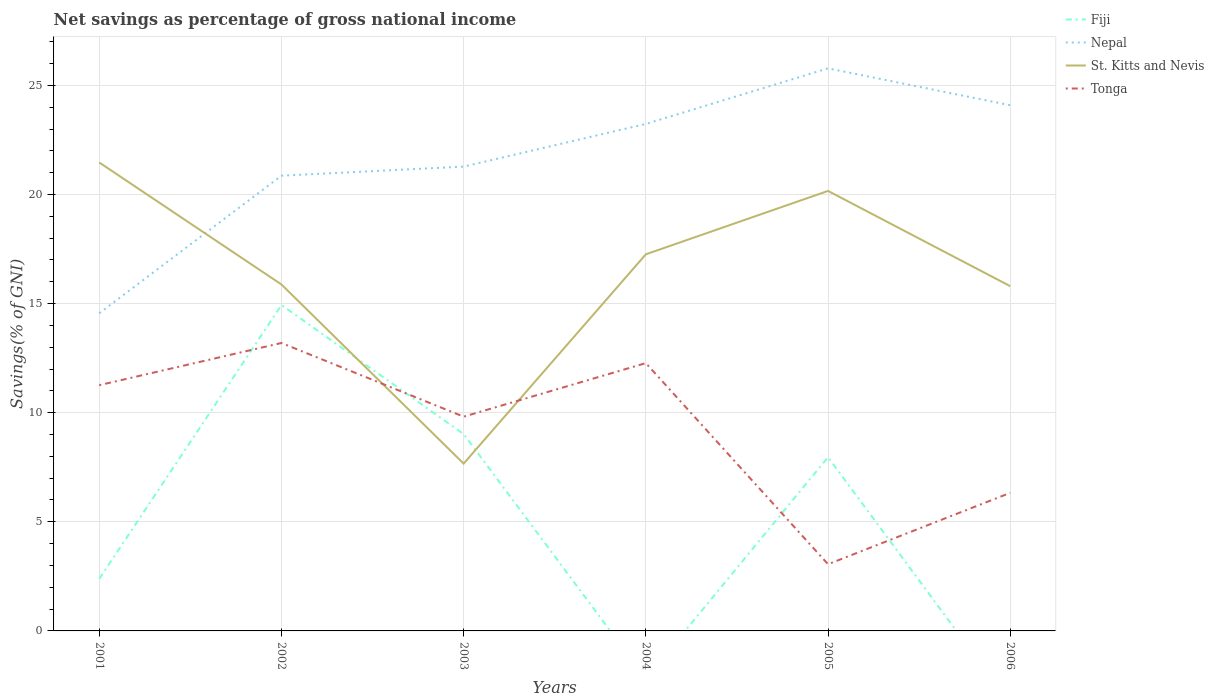What is the total total savings in Tonga in the graph?
Provide a short and direct response. 8.21. What is the difference between the highest and the second highest total savings in Tonga?
Offer a very short reply. 10.14. Are the values on the major ticks of Y-axis written in scientific E-notation?
Keep it short and to the point. No. Does the graph contain any zero values?
Your answer should be very brief. Yes. Does the graph contain grids?
Your answer should be very brief. Yes. How many legend labels are there?
Your answer should be very brief. 4. How are the legend labels stacked?
Keep it short and to the point. Vertical. What is the title of the graph?
Ensure brevity in your answer.  Net savings as percentage of gross national income. What is the label or title of the X-axis?
Keep it short and to the point. Years. What is the label or title of the Y-axis?
Keep it short and to the point. Savings(% of GNI). What is the Savings(% of GNI) in Fiji in 2001?
Offer a very short reply. 2.39. What is the Savings(% of GNI) in Nepal in 2001?
Make the answer very short. 14.56. What is the Savings(% of GNI) in St. Kitts and Nevis in 2001?
Ensure brevity in your answer.  21.47. What is the Savings(% of GNI) in Tonga in 2001?
Your answer should be very brief. 11.26. What is the Savings(% of GNI) in Fiji in 2002?
Give a very brief answer. 14.94. What is the Savings(% of GNI) of Nepal in 2002?
Your response must be concise. 20.86. What is the Savings(% of GNI) in St. Kitts and Nevis in 2002?
Make the answer very short. 15.88. What is the Savings(% of GNI) of Tonga in 2002?
Keep it short and to the point. 13.2. What is the Savings(% of GNI) in Fiji in 2003?
Ensure brevity in your answer.  9.02. What is the Savings(% of GNI) in Nepal in 2003?
Ensure brevity in your answer.  21.28. What is the Savings(% of GNI) in St. Kitts and Nevis in 2003?
Make the answer very short. 7.67. What is the Savings(% of GNI) in Tonga in 2003?
Provide a succinct answer. 9.82. What is the Savings(% of GNI) in Fiji in 2004?
Ensure brevity in your answer.  0. What is the Savings(% of GNI) in Nepal in 2004?
Offer a very short reply. 23.23. What is the Savings(% of GNI) in St. Kitts and Nevis in 2004?
Ensure brevity in your answer.  17.26. What is the Savings(% of GNI) in Tonga in 2004?
Provide a short and direct response. 12.27. What is the Savings(% of GNI) of Fiji in 2005?
Your answer should be very brief. 7.96. What is the Savings(% of GNI) of Nepal in 2005?
Provide a succinct answer. 25.78. What is the Savings(% of GNI) in St. Kitts and Nevis in 2005?
Make the answer very short. 20.16. What is the Savings(% of GNI) in Tonga in 2005?
Offer a terse response. 3.06. What is the Savings(% of GNI) in Fiji in 2006?
Your answer should be compact. 0. What is the Savings(% of GNI) in Nepal in 2006?
Your response must be concise. 24.09. What is the Savings(% of GNI) of St. Kitts and Nevis in 2006?
Provide a succinct answer. 15.8. What is the Savings(% of GNI) in Tonga in 2006?
Provide a short and direct response. 6.33. Across all years, what is the maximum Savings(% of GNI) in Fiji?
Provide a short and direct response. 14.94. Across all years, what is the maximum Savings(% of GNI) of Nepal?
Offer a very short reply. 25.78. Across all years, what is the maximum Savings(% of GNI) of St. Kitts and Nevis?
Ensure brevity in your answer.  21.47. Across all years, what is the maximum Savings(% of GNI) in Tonga?
Offer a terse response. 13.2. Across all years, what is the minimum Savings(% of GNI) in Fiji?
Give a very brief answer. 0. Across all years, what is the minimum Savings(% of GNI) of Nepal?
Give a very brief answer. 14.56. Across all years, what is the minimum Savings(% of GNI) of St. Kitts and Nevis?
Provide a short and direct response. 7.67. Across all years, what is the minimum Savings(% of GNI) of Tonga?
Your response must be concise. 3.06. What is the total Savings(% of GNI) in Fiji in the graph?
Offer a very short reply. 34.3. What is the total Savings(% of GNI) in Nepal in the graph?
Your answer should be very brief. 129.81. What is the total Savings(% of GNI) in St. Kitts and Nevis in the graph?
Offer a terse response. 98.24. What is the total Savings(% of GNI) in Tonga in the graph?
Your response must be concise. 55.93. What is the difference between the Savings(% of GNI) in Fiji in 2001 and that in 2002?
Keep it short and to the point. -12.55. What is the difference between the Savings(% of GNI) of Nepal in 2001 and that in 2002?
Keep it short and to the point. -6.3. What is the difference between the Savings(% of GNI) in St. Kitts and Nevis in 2001 and that in 2002?
Provide a short and direct response. 5.59. What is the difference between the Savings(% of GNI) in Tonga in 2001 and that in 2002?
Ensure brevity in your answer.  -1.93. What is the difference between the Savings(% of GNI) of Fiji in 2001 and that in 2003?
Ensure brevity in your answer.  -6.63. What is the difference between the Savings(% of GNI) of Nepal in 2001 and that in 2003?
Provide a short and direct response. -6.72. What is the difference between the Savings(% of GNI) in St. Kitts and Nevis in 2001 and that in 2003?
Make the answer very short. 13.8. What is the difference between the Savings(% of GNI) in Tonga in 2001 and that in 2003?
Give a very brief answer. 1.44. What is the difference between the Savings(% of GNI) of Nepal in 2001 and that in 2004?
Keep it short and to the point. -8.68. What is the difference between the Savings(% of GNI) of St. Kitts and Nevis in 2001 and that in 2004?
Ensure brevity in your answer.  4.21. What is the difference between the Savings(% of GNI) of Tonga in 2001 and that in 2004?
Offer a very short reply. -1.01. What is the difference between the Savings(% of GNI) of Fiji in 2001 and that in 2005?
Make the answer very short. -5.58. What is the difference between the Savings(% of GNI) in Nepal in 2001 and that in 2005?
Your answer should be compact. -11.22. What is the difference between the Savings(% of GNI) of St. Kitts and Nevis in 2001 and that in 2005?
Provide a short and direct response. 1.3. What is the difference between the Savings(% of GNI) in Tonga in 2001 and that in 2005?
Ensure brevity in your answer.  8.21. What is the difference between the Savings(% of GNI) of Nepal in 2001 and that in 2006?
Your answer should be very brief. -9.53. What is the difference between the Savings(% of GNI) of St. Kitts and Nevis in 2001 and that in 2006?
Keep it short and to the point. 5.67. What is the difference between the Savings(% of GNI) in Tonga in 2001 and that in 2006?
Make the answer very short. 4.93. What is the difference between the Savings(% of GNI) in Fiji in 2002 and that in 2003?
Make the answer very short. 5.92. What is the difference between the Savings(% of GNI) of Nepal in 2002 and that in 2003?
Keep it short and to the point. -0.42. What is the difference between the Savings(% of GNI) in St. Kitts and Nevis in 2002 and that in 2003?
Provide a short and direct response. 8.21. What is the difference between the Savings(% of GNI) of Tonga in 2002 and that in 2003?
Provide a short and direct response. 3.38. What is the difference between the Savings(% of GNI) in Nepal in 2002 and that in 2004?
Your response must be concise. -2.37. What is the difference between the Savings(% of GNI) in St. Kitts and Nevis in 2002 and that in 2004?
Your answer should be very brief. -1.38. What is the difference between the Savings(% of GNI) of Tonga in 2002 and that in 2004?
Ensure brevity in your answer.  0.92. What is the difference between the Savings(% of GNI) of Fiji in 2002 and that in 2005?
Offer a terse response. 6.97. What is the difference between the Savings(% of GNI) in Nepal in 2002 and that in 2005?
Give a very brief answer. -4.92. What is the difference between the Savings(% of GNI) in St. Kitts and Nevis in 2002 and that in 2005?
Offer a terse response. -4.29. What is the difference between the Savings(% of GNI) of Tonga in 2002 and that in 2005?
Keep it short and to the point. 10.14. What is the difference between the Savings(% of GNI) in Nepal in 2002 and that in 2006?
Provide a succinct answer. -3.23. What is the difference between the Savings(% of GNI) in St. Kitts and Nevis in 2002 and that in 2006?
Provide a short and direct response. 0.08. What is the difference between the Savings(% of GNI) in Tonga in 2002 and that in 2006?
Ensure brevity in your answer.  6.87. What is the difference between the Savings(% of GNI) in Nepal in 2003 and that in 2004?
Your response must be concise. -1.96. What is the difference between the Savings(% of GNI) of St. Kitts and Nevis in 2003 and that in 2004?
Ensure brevity in your answer.  -9.59. What is the difference between the Savings(% of GNI) in Tonga in 2003 and that in 2004?
Make the answer very short. -2.45. What is the difference between the Savings(% of GNI) of Fiji in 2003 and that in 2005?
Give a very brief answer. 1.06. What is the difference between the Savings(% of GNI) of Nepal in 2003 and that in 2005?
Offer a very short reply. -4.5. What is the difference between the Savings(% of GNI) in St. Kitts and Nevis in 2003 and that in 2005?
Ensure brevity in your answer.  -12.5. What is the difference between the Savings(% of GNI) in Tonga in 2003 and that in 2005?
Ensure brevity in your answer.  6.76. What is the difference between the Savings(% of GNI) of Nepal in 2003 and that in 2006?
Your answer should be very brief. -2.81. What is the difference between the Savings(% of GNI) of St. Kitts and Nevis in 2003 and that in 2006?
Your answer should be compact. -8.13. What is the difference between the Savings(% of GNI) in Tonga in 2003 and that in 2006?
Your answer should be compact. 3.49. What is the difference between the Savings(% of GNI) in Nepal in 2004 and that in 2005?
Offer a terse response. -2.55. What is the difference between the Savings(% of GNI) in St. Kitts and Nevis in 2004 and that in 2005?
Offer a terse response. -2.9. What is the difference between the Savings(% of GNI) of Tonga in 2004 and that in 2005?
Your answer should be very brief. 9.22. What is the difference between the Savings(% of GNI) of Nepal in 2004 and that in 2006?
Your answer should be very brief. -0.86. What is the difference between the Savings(% of GNI) in St. Kitts and Nevis in 2004 and that in 2006?
Give a very brief answer. 1.46. What is the difference between the Savings(% of GNI) in Tonga in 2004 and that in 2006?
Your answer should be compact. 5.95. What is the difference between the Savings(% of GNI) of Nepal in 2005 and that in 2006?
Ensure brevity in your answer.  1.69. What is the difference between the Savings(% of GNI) in St. Kitts and Nevis in 2005 and that in 2006?
Keep it short and to the point. 4.36. What is the difference between the Savings(% of GNI) in Tonga in 2005 and that in 2006?
Give a very brief answer. -3.27. What is the difference between the Savings(% of GNI) in Fiji in 2001 and the Savings(% of GNI) in Nepal in 2002?
Your answer should be very brief. -18.48. What is the difference between the Savings(% of GNI) of Fiji in 2001 and the Savings(% of GNI) of St. Kitts and Nevis in 2002?
Provide a succinct answer. -13.49. What is the difference between the Savings(% of GNI) of Fiji in 2001 and the Savings(% of GNI) of Tonga in 2002?
Offer a very short reply. -10.81. What is the difference between the Savings(% of GNI) of Nepal in 2001 and the Savings(% of GNI) of St. Kitts and Nevis in 2002?
Your answer should be very brief. -1.32. What is the difference between the Savings(% of GNI) in Nepal in 2001 and the Savings(% of GNI) in Tonga in 2002?
Ensure brevity in your answer.  1.36. What is the difference between the Savings(% of GNI) in St. Kitts and Nevis in 2001 and the Savings(% of GNI) in Tonga in 2002?
Give a very brief answer. 8.27. What is the difference between the Savings(% of GNI) of Fiji in 2001 and the Savings(% of GNI) of Nepal in 2003?
Make the answer very short. -18.89. What is the difference between the Savings(% of GNI) of Fiji in 2001 and the Savings(% of GNI) of St. Kitts and Nevis in 2003?
Your response must be concise. -5.28. What is the difference between the Savings(% of GNI) of Fiji in 2001 and the Savings(% of GNI) of Tonga in 2003?
Keep it short and to the point. -7.43. What is the difference between the Savings(% of GNI) of Nepal in 2001 and the Savings(% of GNI) of St. Kitts and Nevis in 2003?
Your answer should be compact. 6.89. What is the difference between the Savings(% of GNI) in Nepal in 2001 and the Savings(% of GNI) in Tonga in 2003?
Your response must be concise. 4.74. What is the difference between the Savings(% of GNI) of St. Kitts and Nevis in 2001 and the Savings(% of GNI) of Tonga in 2003?
Offer a terse response. 11.65. What is the difference between the Savings(% of GNI) of Fiji in 2001 and the Savings(% of GNI) of Nepal in 2004?
Provide a succinct answer. -20.85. What is the difference between the Savings(% of GNI) in Fiji in 2001 and the Savings(% of GNI) in St. Kitts and Nevis in 2004?
Your response must be concise. -14.87. What is the difference between the Savings(% of GNI) in Fiji in 2001 and the Savings(% of GNI) in Tonga in 2004?
Give a very brief answer. -9.89. What is the difference between the Savings(% of GNI) of Nepal in 2001 and the Savings(% of GNI) of St. Kitts and Nevis in 2004?
Your response must be concise. -2.7. What is the difference between the Savings(% of GNI) in Nepal in 2001 and the Savings(% of GNI) in Tonga in 2004?
Your answer should be compact. 2.29. What is the difference between the Savings(% of GNI) in St. Kitts and Nevis in 2001 and the Savings(% of GNI) in Tonga in 2004?
Ensure brevity in your answer.  9.2. What is the difference between the Savings(% of GNI) of Fiji in 2001 and the Savings(% of GNI) of Nepal in 2005?
Make the answer very short. -23.4. What is the difference between the Savings(% of GNI) of Fiji in 2001 and the Savings(% of GNI) of St. Kitts and Nevis in 2005?
Provide a succinct answer. -17.78. What is the difference between the Savings(% of GNI) in Fiji in 2001 and the Savings(% of GNI) in Tonga in 2005?
Give a very brief answer. -0.67. What is the difference between the Savings(% of GNI) of Nepal in 2001 and the Savings(% of GNI) of St. Kitts and Nevis in 2005?
Give a very brief answer. -5.6. What is the difference between the Savings(% of GNI) in Nepal in 2001 and the Savings(% of GNI) in Tonga in 2005?
Your response must be concise. 11.5. What is the difference between the Savings(% of GNI) of St. Kitts and Nevis in 2001 and the Savings(% of GNI) of Tonga in 2005?
Make the answer very short. 18.41. What is the difference between the Savings(% of GNI) of Fiji in 2001 and the Savings(% of GNI) of Nepal in 2006?
Provide a succinct answer. -21.71. What is the difference between the Savings(% of GNI) in Fiji in 2001 and the Savings(% of GNI) in St. Kitts and Nevis in 2006?
Your answer should be compact. -13.41. What is the difference between the Savings(% of GNI) of Fiji in 2001 and the Savings(% of GNI) of Tonga in 2006?
Provide a succinct answer. -3.94. What is the difference between the Savings(% of GNI) of Nepal in 2001 and the Savings(% of GNI) of St. Kitts and Nevis in 2006?
Keep it short and to the point. -1.24. What is the difference between the Savings(% of GNI) in Nepal in 2001 and the Savings(% of GNI) in Tonga in 2006?
Provide a short and direct response. 8.23. What is the difference between the Savings(% of GNI) of St. Kitts and Nevis in 2001 and the Savings(% of GNI) of Tonga in 2006?
Give a very brief answer. 15.14. What is the difference between the Savings(% of GNI) of Fiji in 2002 and the Savings(% of GNI) of Nepal in 2003?
Ensure brevity in your answer.  -6.34. What is the difference between the Savings(% of GNI) in Fiji in 2002 and the Savings(% of GNI) in St. Kitts and Nevis in 2003?
Ensure brevity in your answer.  7.27. What is the difference between the Savings(% of GNI) in Fiji in 2002 and the Savings(% of GNI) in Tonga in 2003?
Your answer should be compact. 5.12. What is the difference between the Savings(% of GNI) of Nepal in 2002 and the Savings(% of GNI) of St. Kitts and Nevis in 2003?
Ensure brevity in your answer.  13.2. What is the difference between the Savings(% of GNI) of Nepal in 2002 and the Savings(% of GNI) of Tonga in 2003?
Your answer should be very brief. 11.04. What is the difference between the Savings(% of GNI) in St. Kitts and Nevis in 2002 and the Savings(% of GNI) in Tonga in 2003?
Provide a succinct answer. 6.06. What is the difference between the Savings(% of GNI) in Fiji in 2002 and the Savings(% of GNI) in Nepal in 2004?
Ensure brevity in your answer.  -8.3. What is the difference between the Savings(% of GNI) in Fiji in 2002 and the Savings(% of GNI) in St. Kitts and Nevis in 2004?
Your answer should be very brief. -2.32. What is the difference between the Savings(% of GNI) of Fiji in 2002 and the Savings(% of GNI) of Tonga in 2004?
Offer a very short reply. 2.66. What is the difference between the Savings(% of GNI) of Nepal in 2002 and the Savings(% of GNI) of St. Kitts and Nevis in 2004?
Keep it short and to the point. 3.6. What is the difference between the Savings(% of GNI) in Nepal in 2002 and the Savings(% of GNI) in Tonga in 2004?
Your response must be concise. 8.59. What is the difference between the Savings(% of GNI) in St. Kitts and Nevis in 2002 and the Savings(% of GNI) in Tonga in 2004?
Your answer should be compact. 3.6. What is the difference between the Savings(% of GNI) of Fiji in 2002 and the Savings(% of GNI) of Nepal in 2005?
Provide a succinct answer. -10.85. What is the difference between the Savings(% of GNI) in Fiji in 2002 and the Savings(% of GNI) in St. Kitts and Nevis in 2005?
Provide a short and direct response. -5.23. What is the difference between the Savings(% of GNI) of Fiji in 2002 and the Savings(% of GNI) of Tonga in 2005?
Offer a terse response. 11.88. What is the difference between the Savings(% of GNI) of Nepal in 2002 and the Savings(% of GNI) of St. Kitts and Nevis in 2005?
Your answer should be very brief. 0.7. What is the difference between the Savings(% of GNI) in Nepal in 2002 and the Savings(% of GNI) in Tonga in 2005?
Your answer should be compact. 17.81. What is the difference between the Savings(% of GNI) of St. Kitts and Nevis in 2002 and the Savings(% of GNI) of Tonga in 2005?
Make the answer very short. 12.82. What is the difference between the Savings(% of GNI) of Fiji in 2002 and the Savings(% of GNI) of Nepal in 2006?
Provide a succinct answer. -9.16. What is the difference between the Savings(% of GNI) of Fiji in 2002 and the Savings(% of GNI) of St. Kitts and Nevis in 2006?
Ensure brevity in your answer.  -0.86. What is the difference between the Savings(% of GNI) of Fiji in 2002 and the Savings(% of GNI) of Tonga in 2006?
Offer a very short reply. 8.61. What is the difference between the Savings(% of GNI) of Nepal in 2002 and the Savings(% of GNI) of St. Kitts and Nevis in 2006?
Ensure brevity in your answer.  5.06. What is the difference between the Savings(% of GNI) of Nepal in 2002 and the Savings(% of GNI) of Tonga in 2006?
Keep it short and to the point. 14.54. What is the difference between the Savings(% of GNI) of St. Kitts and Nevis in 2002 and the Savings(% of GNI) of Tonga in 2006?
Provide a short and direct response. 9.55. What is the difference between the Savings(% of GNI) in Fiji in 2003 and the Savings(% of GNI) in Nepal in 2004?
Keep it short and to the point. -14.21. What is the difference between the Savings(% of GNI) in Fiji in 2003 and the Savings(% of GNI) in St. Kitts and Nevis in 2004?
Keep it short and to the point. -8.24. What is the difference between the Savings(% of GNI) of Fiji in 2003 and the Savings(% of GNI) of Tonga in 2004?
Provide a succinct answer. -3.25. What is the difference between the Savings(% of GNI) in Nepal in 2003 and the Savings(% of GNI) in St. Kitts and Nevis in 2004?
Your response must be concise. 4.02. What is the difference between the Savings(% of GNI) of Nepal in 2003 and the Savings(% of GNI) of Tonga in 2004?
Your answer should be very brief. 9.01. What is the difference between the Savings(% of GNI) of St. Kitts and Nevis in 2003 and the Savings(% of GNI) of Tonga in 2004?
Your answer should be very brief. -4.61. What is the difference between the Savings(% of GNI) in Fiji in 2003 and the Savings(% of GNI) in Nepal in 2005?
Offer a terse response. -16.76. What is the difference between the Savings(% of GNI) in Fiji in 2003 and the Savings(% of GNI) in St. Kitts and Nevis in 2005?
Your answer should be compact. -11.14. What is the difference between the Savings(% of GNI) in Fiji in 2003 and the Savings(% of GNI) in Tonga in 2005?
Give a very brief answer. 5.96. What is the difference between the Savings(% of GNI) in Nepal in 2003 and the Savings(% of GNI) in St. Kitts and Nevis in 2005?
Ensure brevity in your answer.  1.11. What is the difference between the Savings(% of GNI) in Nepal in 2003 and the Savings(% of GNI) in Tonga in 2005?
Ensure brevity in your answer.  18.22. What is the difference between the Savings(% of GNI) in St. Kitts and Nevis in 2003 and the Savings(% of GNI) in Tonga in 2005?
Your answer should be compact. 4.61. What is the difference between the Savings(% of GNI) of Fiji in 2003 and the Savings(% of GNI) of Nepal in 2006?
Offer a very short reply. -15.07. What is the difference between the Savings(% of GNI) of Fiji in 2003 and the Savings(% of GNI) of St. Kitts and Nevis in 2006?
Your response must be concise. -6.78. What is the difference between the Savings(% of GNI) of Fiji in 2003 and the Savings(% of GNI) of Tonga in 2006?
Your response must be concise. 2.69. What is the difference between the Savings(% of GNI) in Nepal in 2003 and the Savings(% of GNI) in St. Kitts and Nevis in 2006?
Your answer should be compact. 5.48. What is the difference between the Savings(% of GNI) of Nepal in 2003 and the Savings(% of GNI) of Tonga in 2006?
Provide a succinct answer. 14.95. What is the difference between the Savings(% of GNI) of St. Kitts and Nevis in 2003 and the Savings(% of GNI) of Tonga in 2006?
Your response must be concise. 1.34. What is the difference between the Savings(% of GNI) of Nepal in 2004 and the Savings(% of GNI) of St. Kitts and Nevis in 2005?
Your answer should be compact. 3.07. What is the difference between the Savings(% of GNI) of Nepal in 2004 and the Savings(% of GNI) of Tonga in 2005?
Provide a succinct answer. 20.18. What is the difference between the Savings(% of GNI) in St. Kitts and Nevis in 2004 and the Savings(% of GNI) in Tonga in 2005?
Give a very brief answer. 14.2. What is the difference between the Savings(% of GNI) in Nepal in 2004 and the Savings(% of GNI) in St. Kitts and Nevis in 2006?
Provide a succinct answer. 7.44. What is the difference between the Savings(% of GNI) of Nepal in 2004 and the Savings(% of GNI) of Tonga in 2006?
Give a very brief answer. 16.91. What is the difference between the Savings(% of GNI) in St. Kitts and Nevis in 2004 and the Savings(% of GNI) in Tonga in 2006?
Your response must be concise. 10.93. What is the difference between the Savings(% of GNI) of Fiji in 2005 and the Savings(% of GNI) of Nepal in 2006?
Provide a succinct answer. -16.13. What is the difference between the Savings(% of GNI) in Fiji in 2005 and the Savings(% of GNI) in St. Kitts and Nevis in 2006?
Give a very brief answer. -7.84. What is the difference between the Savings(% of GNI) of Fiji in 2005 and the Savings(% of GNI) of Tonga in 2006?
Offer a very short reply. 1.63. What is the difference between the Savings(% of GNI) of Nepal in 2005 and the Savings(% of GNI) of St. Kitts and Nevis in 2006?
Your response must be concise. 9.98. What is the difference between the Savings(% of GNI) in Nepal in 2005 and the Savings(% of GNI) in Tonga in 2006?
Your answer should be very brief. 19.45. What is the difference between the Savings(% of GNI) of St. Kitts and Nevis in 2005 and the Savings(% of GNI) of Tonga in 2006?
Ensure brevity in your answer.  13.84. What is the average Savings(% of GNI) of Fiji per year?
Offer a very short reply. 5.72. What is the average Savings(% of GNI) of Nepal per year?
Ensure brevity in your answer.  21.64. What is the average Savings(% of GNI) in St. Kitts and Nevis per year?
Provide a succinct answer. 16.37. What is the average Savings(% of GNI) in Tonga per year?
Make the answer very short. 9.32. In the year 2001, what is the difference between the Savings(% of GNI) in Fiji and Savings(% of GNI) in Nepal?
Your response must be concise. -12.17. In the year 2001, what is the difference between the Savings(% of GNI) in Fiji and Savings(% of GNI) in St. Kitts and Nevis?
Provide a succinct answer. -19.08. In the year 2001, what is the difference between the Savings(% of GNI) in Fiji and Savings(% of GNI) in Tonga?
Provide a succinct answer. -8.88. In the year 2001, what is the difference between the Savings(% of GNI) of Nepal and Savings(% of GNI) of St. Kitts and Nevis?
Offer a terse response. -6.91. In the year 2001, what is the difference between the Savings(% of GNI) in Nepal and Savings(% of GNI) in Tonga?
Your answer should be compact. 3.3. In the year 2001, what is the difference between the Savings(% of GNI) of St. Kitts and Nevis and Savings(% of GNI) of Tonga?
Your answer should be very brief. 10.21. In the year 2002, what is the difference between the Savings(% of GNI) of Fiji and Savings(% of GNI) of Nepal?
Your answer should be compact. -5.93. In the year 2002, what is the difference between the Savings(% of GNI) in Fiji and Savings(% of GNI) in St. Kitts and Nevis?
Your response must be concise. -0.94. In the year 2002, what is the difference between the Savings(% of GNI) of Fiji and Savings(% of GNI) of Tonga?
Ensure brevity in your answer.  1.74. In the year 2002, what is the difference between the Savings(% of GNI) of Nepal and Savings(% of GNI) of St. Kitts and Nevis?
Provide a short and direct response. 4.99. In the year 2002, what is the difference between the Savings(% of GNI) in Nepal and Savings(% of GNI) in Tonga?
Your response must be concise. 7.67. In the year 2002, what is the difference between the Savings(% of GNI) in St. Kitts and Nevis and Savings(% of GNI) in Tonga?
Keep it short and to the point. 2.68. In the year 2003, what is the difference between the Savings(% of GNI) of Fiji and Savings(% of GNI) of Nepal?
Your answer should be very brief. -12.26. In the year 2003, what is the difference between the Savings(% of GNI) of Fiji and Savings(% of GNI) of St. Kitts and Nevis?
Provide a short and direct response. 1.35. In the year 2003, what is the difference between the Savings(% of GNI) in Fiji and Savings(% of GNI) in Tonga?
Offer a terse response. -0.8. In the year 2003, what is the difference between the Savings(% of GNI) in Nepal and Savings(% of GNI) in St. Kitts and Nevis?
Your answer should be compact. 13.61. In the year 2003, what is the difference between the Savings(% of GNI) of Nepal and Savings(% of GNI) of Tonga?
Ensure brevity in your answer.  11.46. In the year 2003, what is the difference between the Savings(% of GNI) of St. Kitts and Nevis and Savings(% of GNI) of Tonga?
Make the answer very short. -2.15. In the year 2004, what is the difference between the Savings(% of GNI) of Nepal and Savings(% of GNI) of St. Kitts and Nevis?
Provide a succinct answer. 5.97. In the year 2004, what is the difference between the Savings(% of GNI) of Nepal and Savings(% of GNI) of Tonga?
Give a very brief answer. 10.96. In the year 2004, what is the difference between the Savings(% of GNI) of St. Kitts and Nevis and Savings(% of GNI) of Tonga?
Your answer should be very brief. 4.99. In the year 2005, what is the difference between the Savings(% of GNI) of Fiji and Savings(% of GNI) of Nepal?
Your response must be concise. -17.82. In the year 2005, what is the difference between the Savings(% of GNI) of Fiji and Savings(% of GNI) of St. Kitts and Nevis?
Keep it short and to the point. -12.2. In the year 2005, what is the difference between the Savings(% of GNI) in Fiji and Savings(% of GNI) in Tonga?
Ensure brevity in your answer.  4.91. In the year 2005, what is the difference between the Savings(% of GNI) in Nepal and Savings(% of GNI) in St. Kitts and Nevis?
Your answer should be compact. 5.62. In the year 2005, what is the difference between the Savings(% of GNI) of Nepal and Savings(% of GNI) of Tonga?
Offer a terse response. 22.73. In the year 2005, what is the difference between the Savings(% of GNI) of St. Kitts and Nevis and Savings(% of GNI) of Tonga?
Keep it short and to the point. 17.11. In the year 2006, what is the difference between the Savings(% of GNI) of Nepal and Savings(% of GNI) of St. Kitts and Nevis?
Provide a short and direct response. 8.29. In the year 2006, what is the difference between the Savings(% of GNI) of Nepal and Savings(% of GNI) of Tonga?
Your response must be concise. 17.76. In the year 2006, what is the difference between the Savings(% of GNI) of St. Kitts and Nevis and Savings(% of GNI) of Tonga?
Your answer should be compact. 9.47. What is the ratio of the Savings(% of GNI) of Fiji in 2001 to that in 2002?
Your answer should be compact. 0.16. What is the ratio of the Savings(% of GNI) of Nepal in 2001 to that in 2002?
Provide a succinct answer. 0.7. What is the ratio of the Savings(% of GNI) in St. Kitts and Nevis in 2001 to that in 2002?
Your answer should be very brief. 1.35. What is the ratio of the Savings(% of GNI) of Tonga in 2001 to that in 2002?
Keep it short and to the point. 0.85. What is the ratio of the Savings(% of GNI) in Fiji in 2001 to that in 2003?
Your response must be concise. 0.26. What is the ratio of the Savings(% of GNI) of Nepal in 2001 to that in 2003?
Offer a very short reply. 0.68. What is the ratio of the Savings(% of GNI) of St. Kitts and Nevis in 2001 to that in 2003?
Your answer should be very brief. 2.8. What is the ratio of the Savings(% of GNI) in Tonga in 2001 to that in 2003?
Your response must be concise. 1.15. What is the ratio of the Savings(% of GNI) of Nepal in 2001 to that in 2004?
Your answer should be compact. 0.63. What is the ratio of the Savings(% of GNI) in St. Kitts and Nevis in 2001 to that in 2004?
Keep it short and to the point. 1.24. What is the ratio of the Savings(% of GNI) in Tonga in 2001 to that in 2004?
Offer a very short reply. 0.92. What is the ratio of the Savings(% of GNI) in Fiji in 2001 to that in 2005?
Your answer should be compact. 0.3. What is the ratio of the Savings(% of GNI) in Nepal in 2001 to that in 2005?
Your response must be concise. 0.56. What is the ratio of the Savings(% of GNI) of St. Kitts and Nevis in 2001 to that in 2005?
Provide a short and direct response. 1.06. What is the ratio of the Savings(% of GNI) in Tonga in 2001 to that in 2005?
Provide a short and direct response. 3.69. What is the ratio of the Savings(% of GNI) in Nepal in 2001 to that in 2006?
Keep it short and to the point. 0.6. What is the ratio of the Savings(% of GNI) in St. Kitts and Nevis in 2001 to that in 2006?
Give a very brief answer. 1.36. What is the ratio of the Savings(% of GNI) in Tonga in 2001 to that in 2006?
Give a very brief answer. 1.78. What is the ratio of the Savings(% of GNI) of Fiji in 2002 to that in 2003?
Keep it short and to the point. 1.66. What is the ratio of the Savings(% of GNI) in Nepal in 2002 to that in 2003?
Make the answer very short. 0.98. What is the ratio of the Savings(% of GNI) in St. Kitts and Nevis in 2002 to that in 2003?
Keep it short and to the point. 2.07. What is the ratio of the Savings(% of GNI) of Tonga in 2002 to that in 2003?
Offer a terse response. 1.34. What is the ratio of the Savings(% of GNI) in Nepal in 2002 to that in 2004?
Offer a terse response. 0.9. What is the ratio of the Savings(% of GNI) in St. Kitts and Nevis in 2002 to that in 2004?
Give a very brief answer. 0.92. What is the ratio of the Savings(% of GNI) in Tonga in 2002 to that in 2004?
Ensure brevity in your answer.  1.08. What is the ratio of the Savings(% of GNI) of Fiji in 2002 to that in 2005?
Give a very brief answer. 1.88. What is the ratio of the Savings(% of GNI) in Nepal in 2002 to that in 2005?
Make the answer very short. 0.81. What is the ratio of the Savings(% of GNI) of St. Kitts and Nevis in 2002 to that in 2005?
Offer a terse response. 0.79. What is the ratio of the Savings(% of GNI) of Tonga in 2002 to that in 2005?
Provide a short and direct response. 4.32. What is the ratio of the Savings(% of GNI) in Nepal in 2002 to that in 2006?
Your answer should be compact. 0.87. What is the ratio of the Savings(% of GNI) of Tonga in 2002 to that in 2006?
Provide a succinct answer. 2.09. What is the ratio of the Savings(% of GNI) in Nepal in 2003 to that in 2004?
Provide a short and direct response. 0.92. What is the ratio of the Savings(% of GNI) of St. Kitts and Nevis in 2003 to that in 2004?
Give a very brief answer. 0.44. What is the ratio of the Savings(% of GNI) in Tonga in 2003 to that in 2004?
Offer a terse response. 0.8. What is the ratio of the Savings(% of GNI) in Fiji in 2003 to that in 2005?
Your answer should be very brief. 1.13. What is the ratio of the Savings(% of GNI) of Nepal in 2003 to that in 2005?
Provide a short and direct response. 0.83. What is the ratio of the Savings(% of GNI) in St. Kitts and Nevis in 2003 to that in 2005?
Make the answer very short. 0.38. What is the ratio of the Savings(% of GNI) in Tonga in 2003 to that in 2005?
Offer a terse response. 3.21. What is the ratio of the Savings(% of GNI) in Nepal in 2003 to that in 2006?
Give a very brief answer. 0.88. What is the ratio of the Savings(% of GNI) of St. Kitts and Nevis in 2003 to that in 2006?
Offer a very short reply. 0.49. What is the ratio of the Savings(% of GNI) in Tonga in 2003 to that in 2006?
Offer a very short reply. 1.55. What is the ratio of the Savings(% of GNI) in Nepal in 2004 to that in 2005?
Your response must be concise. 0.9. What is the ratio of the Savings(% of GNI) of St. Kitts and Nevis in 2004 to that in 2005?
Give a very brief answer. 0.86. What is the ratio of the Savings(% of GNI) in Tonga in 2004 to that in 2005?
Make the answer very short. 4.02. What is the ratio of the Savings(% of GNI) of Nepal in 2004 to that in 2006?
Provide a short and direct response. 0.96. What is the ratio of the Savings(% of GNI) of St. Kitts and Nevis in 2004 to that in 2006?
Your answer should be very brief. 1.09. What is the ratio of the Savings(% of GNI) of Tonga in 2004 to that in 2006?
Give a very brief answer. 1.94. What is the ratio of the Savings(% of GNI) in Nepal in 2005 to that in 2006?
Keep it short and to the point. 1.07. What is the ratio of the Savings(% of GNI) of St. Kitts and Nevis in 2005 to that in 2006?
Provide a short and direct response. 1.28. What is the ratio of the Savings(% of GNI) in Tonga in 2005 to that in 2006?
Offer a very short reply. 0.48. What is the difference between the highest and the second highest Savings(% of GNI) of Fiji?
Provide a short and direct response. 5.92. What is the difference between the highest and the second highest Savings(% of GNI) of Nepal?
Your answer should be very brief. 1.69. What is the difference between the highest and the second highest Savings(% of GNI) in St. Kitts and Nevis?
Provide a succinct answer. 1.3. What is the difference between the highest and the second highest Savings(% of GNI) of Tonga?
Your response must be concise. 0.92. What is the difference between the highest and the lowest Savings(% of GNI) in Fiji?
Provide a succinct answer. 14.94. What is the difference between the highest and the lowest Savings(% of GNI) in Nepal?
Provide a short and direct response. 11.22. What is the difference between the highest and the lowest Savings(% of GNI) of St. Kitts and Nevis?
Provide a succinct answer. 13.8. What is the difference between the highest and the lowest Savings(% of GNI) in Tonga?
Make the answer very short. 10.14. 